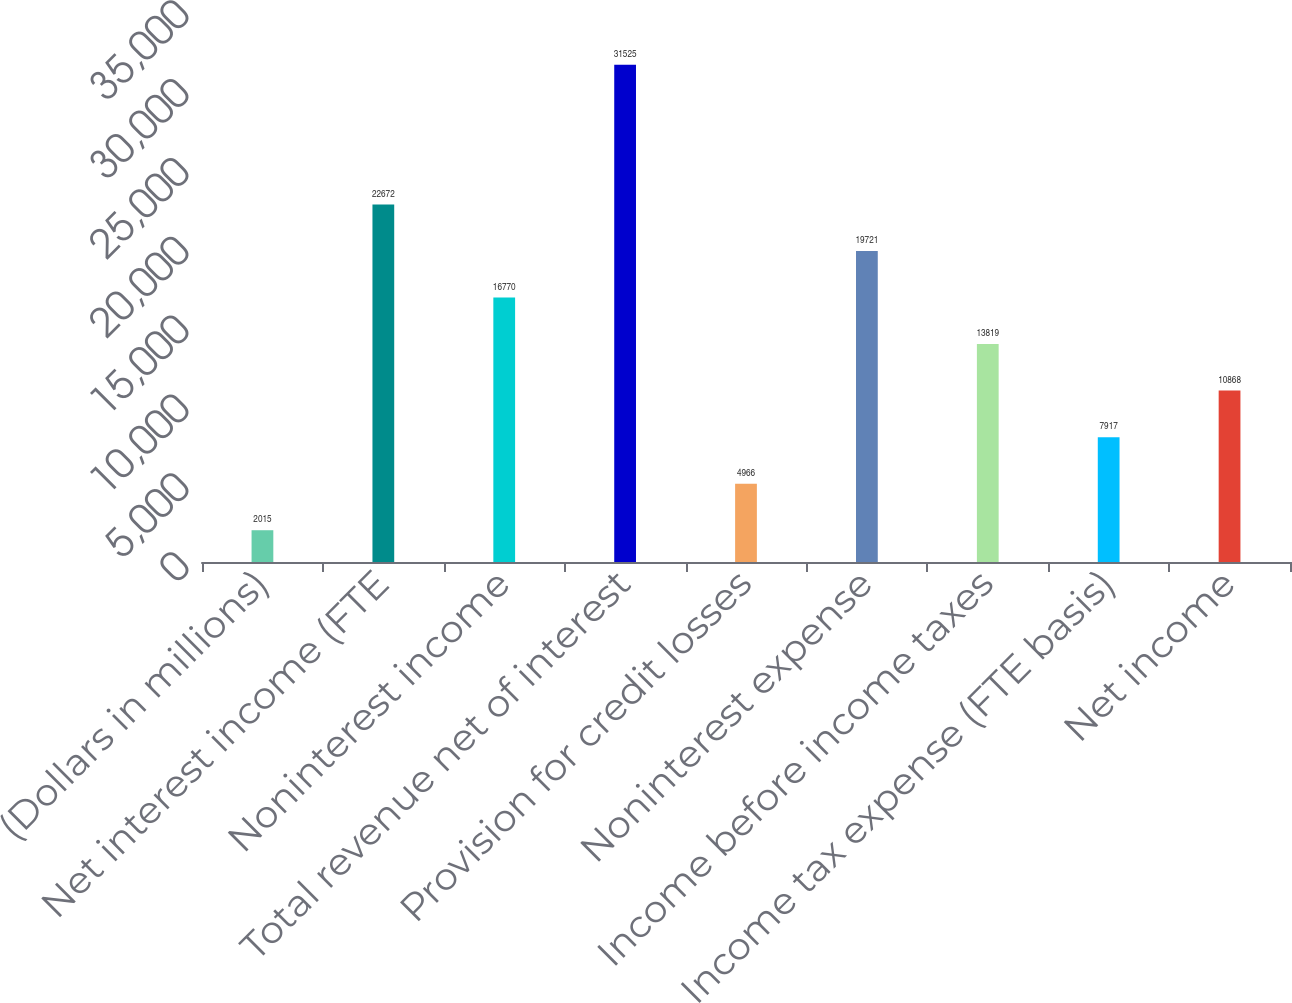Convert chart. <chart><loc_0><loc_0><loc_500><loc_500><bar_chart><fcel>(Dollars in millions)<fcel>Net interest income (FTE<fcel>Noninterest income<fcel>Total revenue net of interest<fcel>Provision for credit losses<fcel>Noninterest expense<fcel>Income before income taxes<fcel>Income tax expense (FTE basis)<fcel>Net income<nl><fcel>2015<fcel>22672<fcel>16770<fcel>31525<fcel>4966<fcel>19721<fcel>13819<fcel>7917<fcel>10868<nl></chart> 